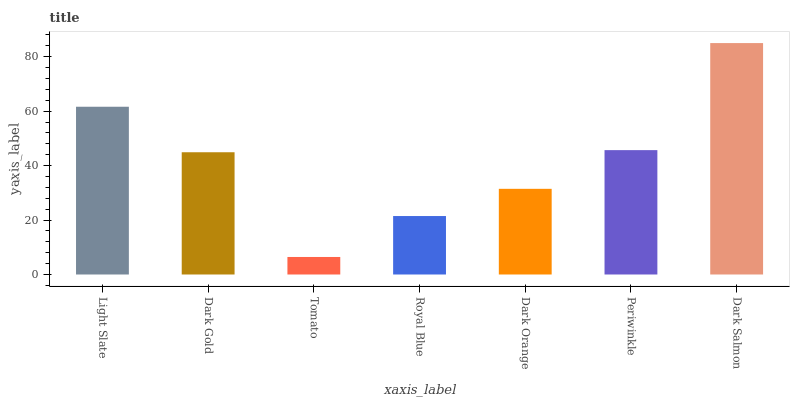Is Dark Gold the minimum?
Answer yes or no. No. Is Dark Gold the maximum?
Answer yes or no. No. Is Light Slate greater than Dark Gold?
Answer yes or no. Yes. Is Dark Gold less than Light Slate?
Answer yes or no. Yes. Is Dark Gold greater than Light Slate?
Answer yes or no. No. Is Light Slate less than Dark Gold?
Answer yes or no. No. Is Dark Gold the high median?
Answer yes or no. Yes. Is Dark Gold the low median?
Answer yes or no. Yes. Is Dark Orange the high median?
Answer yes or no. No. Is Royal Blue the low median?
Answer yes or no. No. 